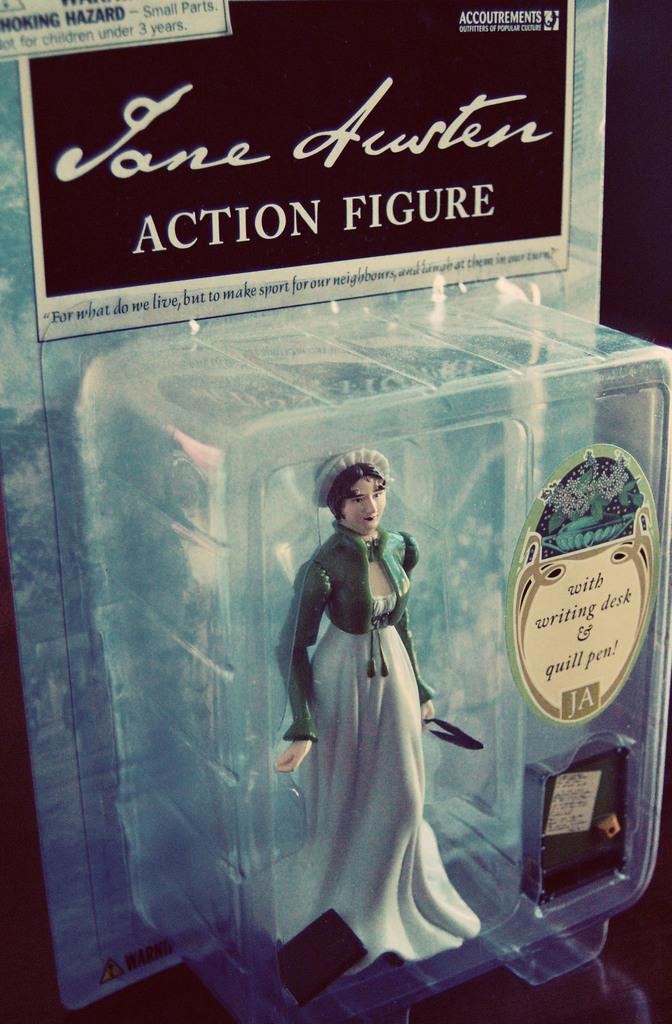What is the main subject of the image? There is a doll in the image. Where is the doll located? The doll is in a box. What else can be seen in the image besides the doll? There are stickers in the image. Can you describe the stickers? The stickers have writing on them. How does the doll's hand move in the image? The doll does not have a hand, as it is an inanimate object. Additionally, the image does not depict any motion or movement. 